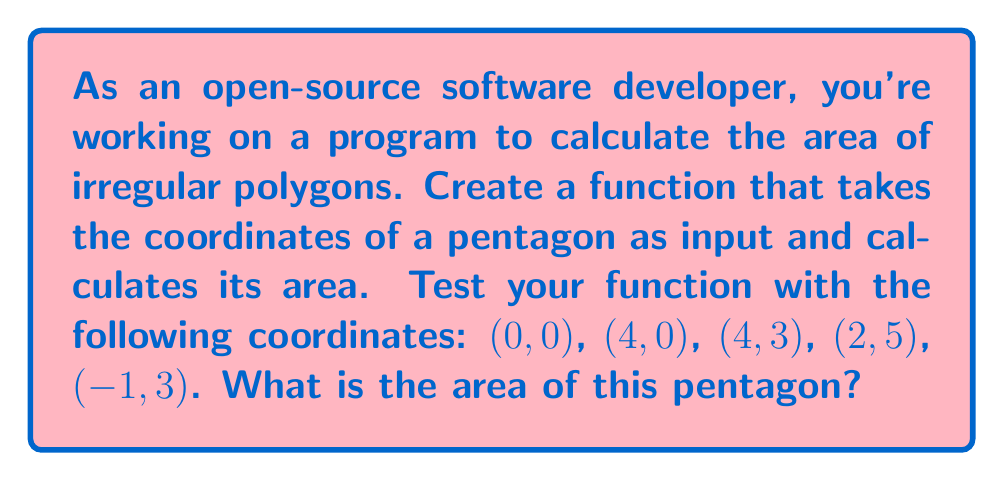Provide a solution to this math problem. To calculate the area of an irregular polygon using coordinate geometry, we can use the Shoelace formula (also known as the surveyor's formula). The steps are as follows:

1. Let's denote the coordinates as $(x_1, y_1)$, $(x_2, y_2)$, ..., $(x_n, y_n)$ where $n$ is the number of vertices.

2. The Shoelace formula is:

   $$A = \frac{1}{2}|(x_1y_2 + x_2y_3 + ... + x_ny_1) - (y_1x_2 + y_2x_3 + ... + y_nx_1)|$$

3. For our pentagon, we have:
   $(x_1, y_1) = (0, 0)$
   $(x_2, y_2) = (4, 0)$
   $(x_3, y_3) = (4, 3)$
   $(x_4, y_4) = (2, 5)$
   $(x_5, y_5) = (-1, 3)$

4. Applying the formula:

   $$A = \frac{1}{2}|(0\cdot0 + 4\cdot3 + 4\cdot5 + 2\cdot3 + (-1)\cdot0) - (0\cdot4 + 0\cdot4 + 3\cdot2 + 5\cdot(-1) + 3\cdot0)|$$

5. Simplifying:

   $$A = \frac{1}{2}|(0 + 12 + 20 + 6 + 0) - (0 + 0 + 6 - 5 + 0)|$$
   $$A = \frac{1}{2}|38 - 1|$$
   $$A = \frac{1}{2}(37)$$
   $$A = 18.5$$

Therefore, the area of the pentagon is 18.5 square units.
Answer: 18.5 square units 